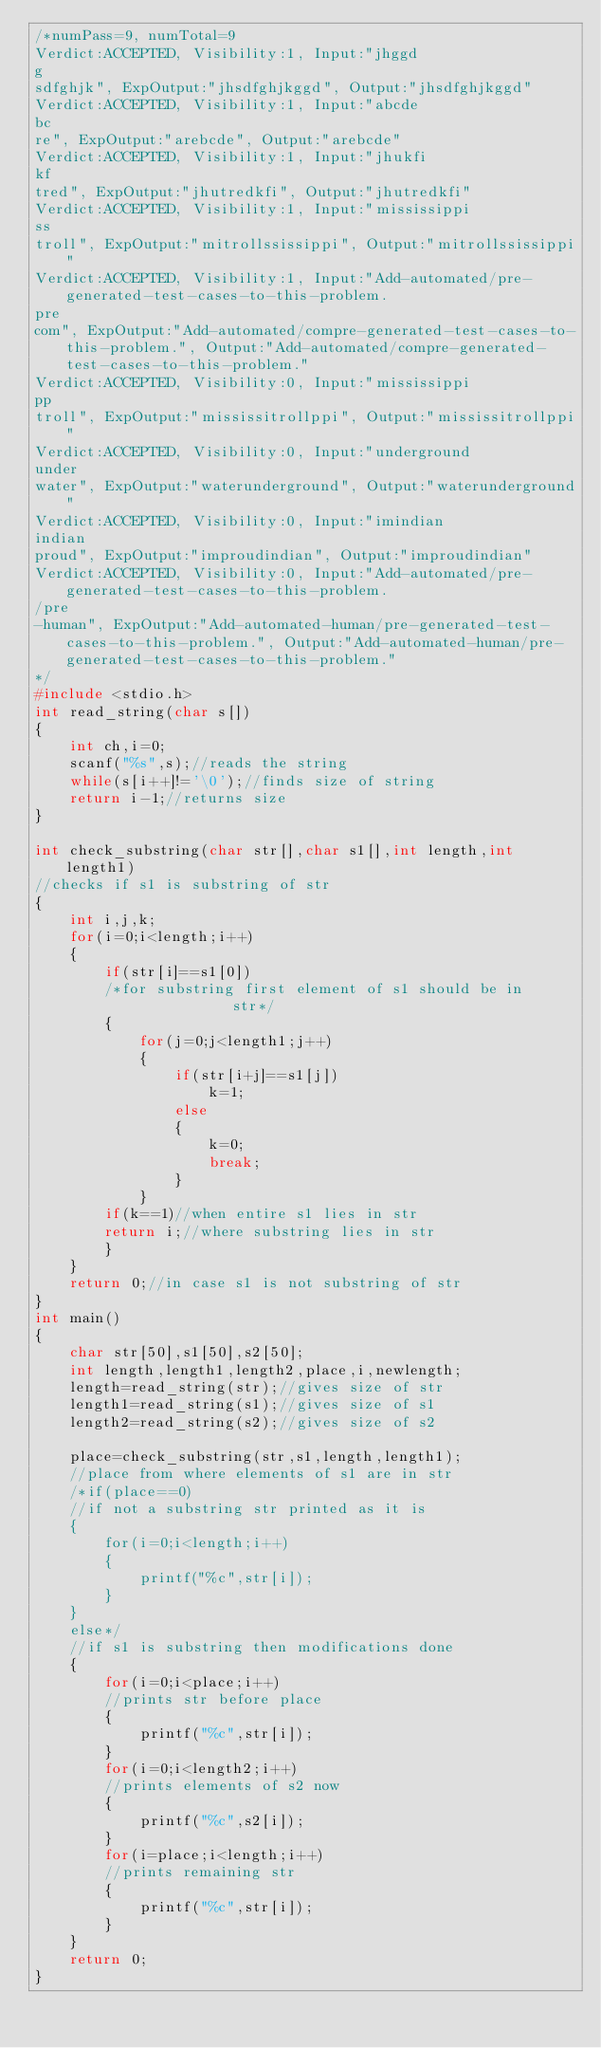<code> <loc_0><loc_0><loc_500><loc_500><_C_>/*numPass=9, numTotal=9
Verdict:ACCEPTED, Visibility:1, Input:"jhggd 
g 
sdfghjk", ExpOutput:"jhsdfghjkggd", Output:"jhsdfghjkggd"
Verdict:ACCEPTED, Visibility:1, Input:"abcde 
bc 
re", ExpOutput:"arebcde", Output:"arebcde"
Verdict:ACCEPTED, Visibility:1, Input:"jhukfi 
kf 
tred", ExpOutput:"jhutredkfi", Output:"jhutredkfi"
Verdict:ACCEPTED, Visibility:1, Input:"mississippi 
ss 
troll", ExpOutput:"mitrollssissippi", Output:"mitrollssissippi"
Verdict:ACCEPTED, Visibility:1, Input:"Add-automated/pre-generated-test-cases-to-this-problem.
pre
com", ExpOutput:"Add-automated/compre-generated-test-cases-to-this-problem.", Output:"Add-automated/compre-generated-test-cases-to-this-problem."
Verdict:ACCEPTED, Visibility:0, Input:"mississippi 
pp 
troll", ExpOutput:"mississitrollppi", Output:"mississitrollppi"
Verdict:ACCEPTED, Visibility:0, Input:"underground
under
water", ExpOutput:"waterunderground", Output:"waterunderground"
Verdict:ACCEPTED, Visibility:0, Input:"imindian 
indian 
proud", ExpOutput:"improudindian", Output:"improudindian"
Verdict:ACCEPTED, Visibility:0, Input:"Add-automated/pre-generated-test-cases-to-this-problem.
/pre
-human", ExpOutput:"Add-automated-human/pre-generated-test-cases-to-this-problem.", Output:"Add-automated-human/pre-generated-test-cases-to-this-problem."
*/
#include <stdio.h>
int read_string(char s[])
{
    int ch,i=0;
    scanf("%s",s);//reads the string
    while(s[i++]!='\0');//finds size of string
    return i-1;//returns size
}

int check_substring(char str[],char s1[],int length,int length1)
//checks if s1 is substring of str
{
    int i,j,k;
    for(i=0;i<length;i++)
    {
        if(str[i]==s1[0])
        /*for substring first element of s1 should be in            str*/
        {
            for(j=0;j<length1;j++)
            {
                if(str[i+j]==s1[j])
                    k=1;
                else
                {
                    k=0;
                    break;
                }
            }
        if(k==1)//when entire s1 lies in str
        return i;//where substring lies in str            
        }
    }
    return 0;//in case s1 is not substring of str
}
int main()
{
    char str[50],s1[50],s2[50];
    int length,length1,length2,place,i,newlength;
	length=read_string(str);//gives size of str
	length1=read_string(s1);//gives size of s1
	length2=read_string(s2);//gives size of s2
	
	place=check_substring(str,s1,length,length1);
	//place from where elements of s1 are in str
	/*if(place==0)
	//if not a substring str printed as it is
	{
	    for(i=0;i<length;i++)
	    {
	        printf("%c",str[i]);
	    }
	}
	else*/
	//if s1 is substring then modifications done
	{
	    for(i=0;i<place;i++)
	    //prints str before place
	    {
	        printf("%c",str[i]);
	    }
	    for(i=0;i<length2;i++)
	    //prints elements of s2 now
	    {
	        printf("%c",s2[i]);
	    }
	    for(i=place;i<length;i++)
	    //prints remaining str
	    {
	        printf("%c",str[i]);
	    }
	}
	return 0;
}</code> 